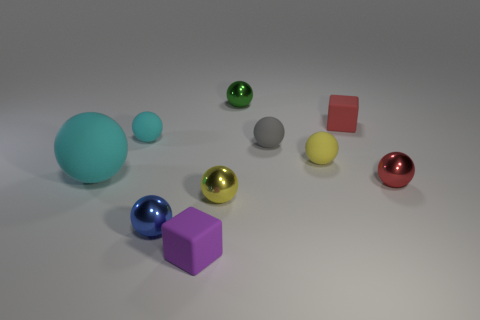There is a gray object that is the same material as the purple cube; what is its size?
Keep it short and to the point. Small. What shape is the cyan rubber thing that is in front of the rubber sphere on the right side of the tiny gray ball?
Provide a succinct answer. Sphere. There is a rubber ball that is to the left of the small blue ball and behind the large cyan sphere; how big is it?
Your response must be concise. Small. Are there any other small things that have the same shape as the tiny blue metallic object?
Provide a short and direct response. Yes. Is there anything else that is the same shape as the purple rubber thing?
Give a very brief answer. Yes. What material is the small cube that is right of the small rubber block on the left side of the tiny matte block that is behind the small purple block?
Make the answer very short. Rubber. Are there any spheres that have the same size as the purple block?
Keep it short and to the point. Yes. There is a tiny ball that is behind the red cube on the left side of the red metallic object; what color is it?
Offer a terse response. Green. How many green matte things are there?
Ensure brevity in your answer.  0. Is the number of purple objects left of the small blue shiny sphere less than the number of small blue spheres that are on the left side of the small green metallic object?
Provide a short and direct response. Yes. 